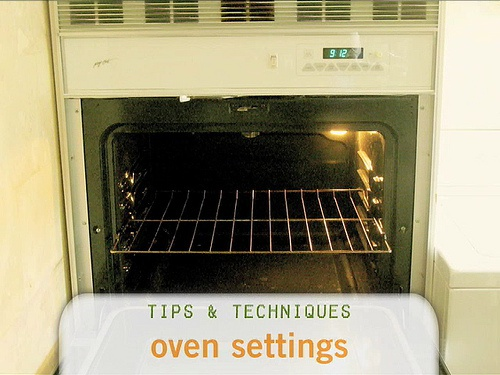Describe the objects in this image and their specific colors. I can see oven in tan, black, khaki, and darkgreen tones and clock in tan, olive, darkgreen, and beige tones in this image. 